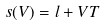<formula> <loc_0><loc_0><loc_500><loc_500>s ( V ) = l + V T</formula> 